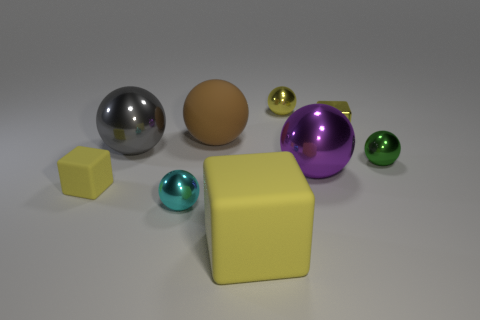Subtract all yellow spheres. How many spheres are left? 5 Subtract all small green metal balls. How many balls are left? 5 Subtract all blue spheres. Subtract all gray cylinders. How many spheres are left? 6 Add 1 large red shiny balls. How many objects exist? 10 Subtract all spheres. How many objects are left? 3 Subtract all small green shiny balls. Subtract all tiny yellow things. How many objects are left? 5 Add 6 blocks. How many blocks are left? 9 Add 9 tiny cyan spheres. How many tiny cyan spheres exist? 10 Subtract 1 purple balls. How many objects are left? 8 